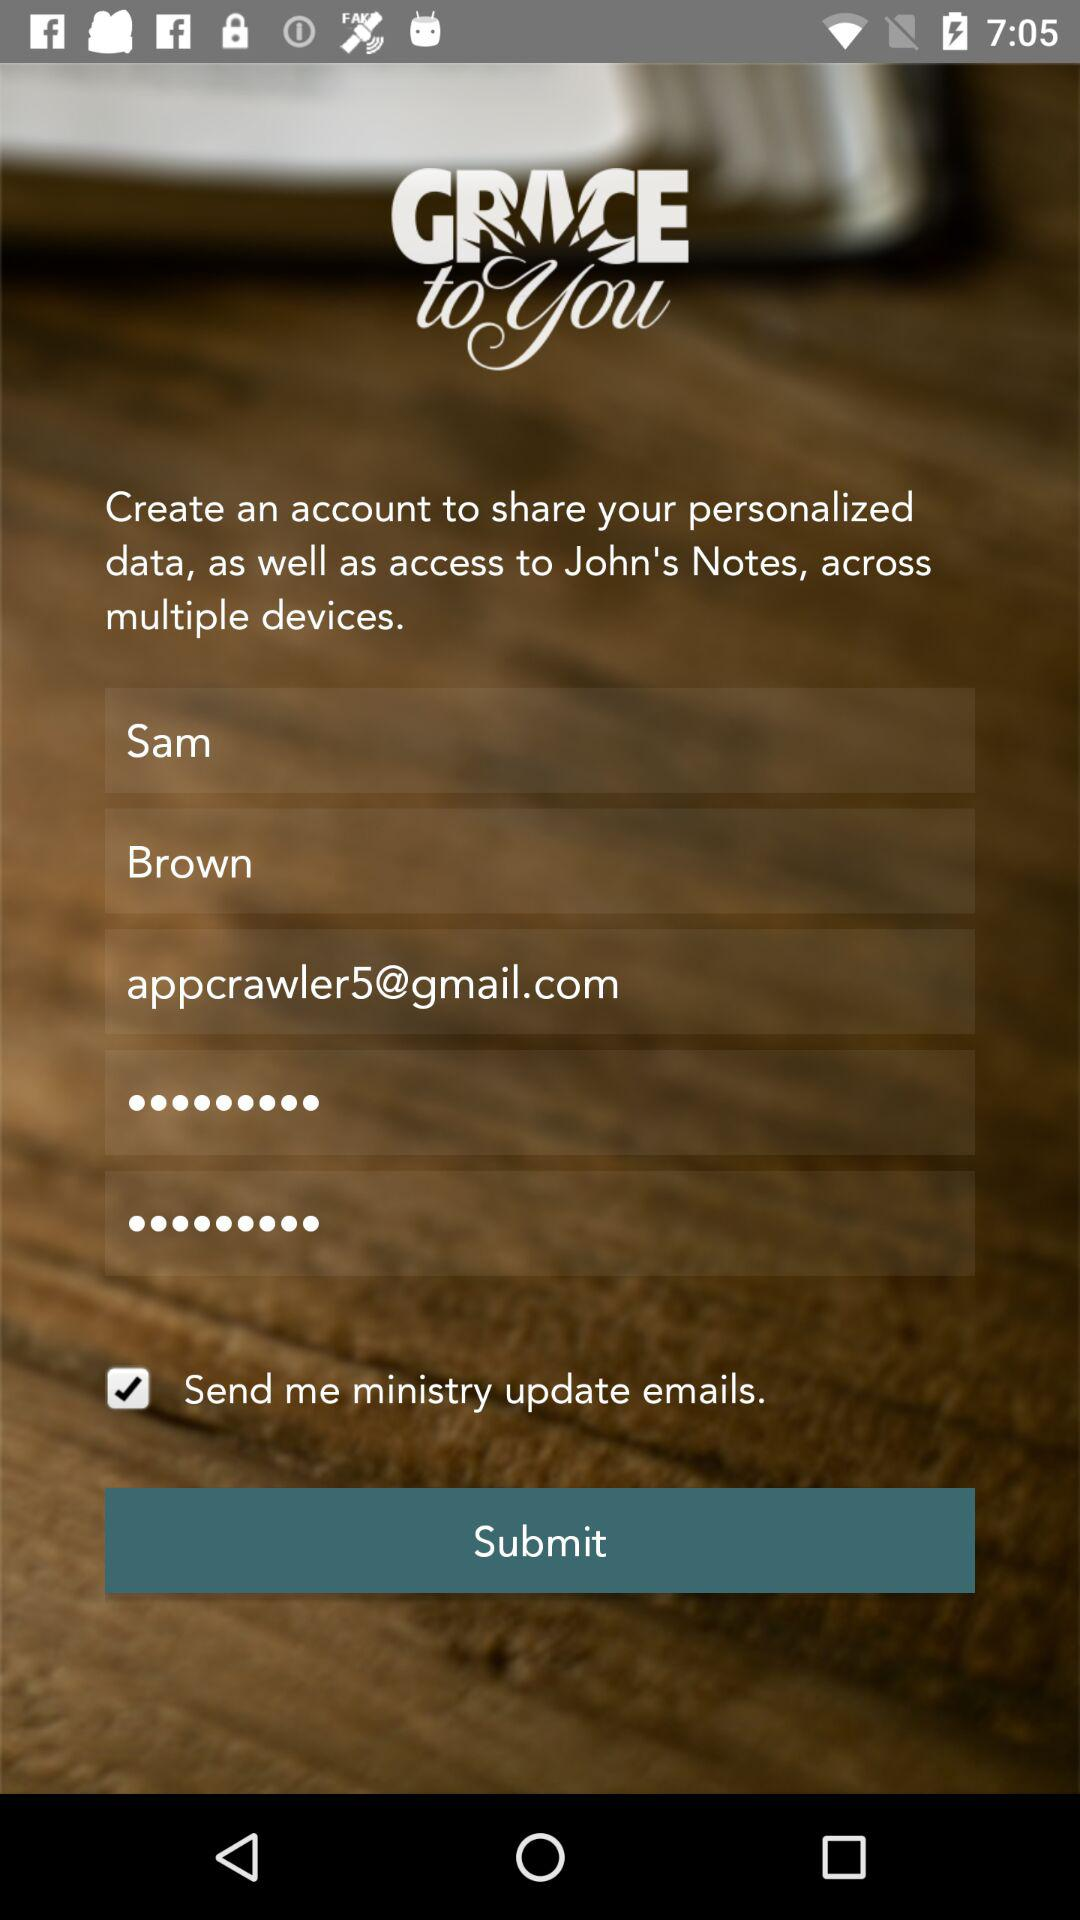What is the name of the person? The name of the person is Sam Brown. 